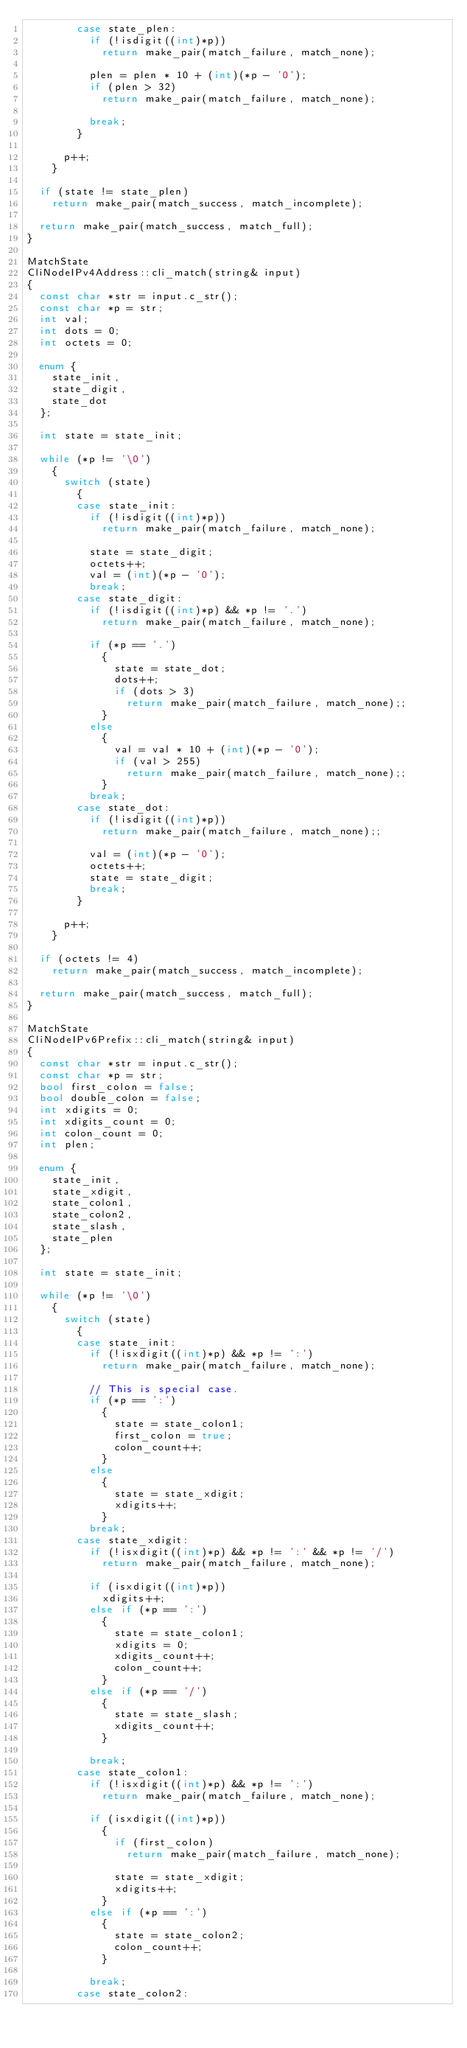<code> <loc_0><loc_0><loc_500><loc_500><_C++_>        case state_plen:
          if (!isdigit((int)*p))
            return make_pair(match_failure, match_none);

          plen = plen * 10 + (int)(*p - '0');
          if (plen > 32)
            return make_pair(match_failure, match_none);

          break;
        }

      p++;
    }

  if (state != state_plen)
    return make_pair(match_success, match_incomplete);

  return make_pair(match_success, match_full);
}

MatchState
CliNodeIPv4Address::cli_match(string& input)
{
  const char *str = input.c_str();
  const char *p = str;
  int val;
  int dots = 0;
  int octets = 0;

  enum {
    state_init,
    state_digit,
    state_dot
  };

  int state = state_init;

  while (*p != '\0')
    {
      switch (state)
        {
        case state_init:
          if (!isdigit((int)*p))
            return make_pair(match_failure, match_none);

          state = state_digit;
          octets++;
          val = (int)(*p - '0');
          break;
        case state_digit:
          if (!isdigit((int)*p) && *p != '.')
            return make_pair(match_failure, match_none);

          if (*p == '.')
            {
              state = state_dot;
              dots++;
              if (dots > 3)
                return make_pair(match_failure, match_none);;
            }
          else
            {
              val = val * 10 + (int)(*p - '0');
              if (val > 255)
                return make_pair(match_failure, match_none);;
            }
          break;
        case state_dot:
          if (!isdigit((int)*p))
            return make_pair(match_failure, match_none);;

          val = (int)(*p - '0');
          octets++;
          state = state_digit;
          break;
        }

      p++;
    }

  if (octets != 4)
    return make_pair(match_success, match_incomplete);

  return make_pair(match_success, match_full);
}

MatchState
CliNodeIPv6Prefix::cli_match(string& input)
{
  const char *str = input.c_str();
  const char *p = str;
  bool first_colon = false;
  bool double_colon = false;
  int xdigits = 0;
  int xdigits_count = 0;
  int colon_count = 0;
  int plen;

  enum {
    state_init,
    state_xdigit,
    state_colon1,
    state_colon2,
    state_slash,
    state_plen
  };

  int state = state_init;

  while (*p != '\0')
    {
      switch (state)
        {
        case state_init:
          if (!isxdigit((int)*p) && *p != ':')
            return make_pair(match_failure, match_none);

          // This is special case.
          if (*p == ':')
            {
              state = state_colon1;
              first_colon = true;
              colon_count++;
            }
          else
            {
              state = state_xdigit;
              xdigits++;
            }
          break;
        case state_xdigit:
          if (!isxdigit((int)*p) && *p != ':' && *p != '/')
            return make_pair(match_failure, match_none);

          if (isxdigit((int)*p))
            xdigits++;
          else if (*p == ':')
            {
              state = state_colon1;
              xdigits = 0;
              xdigits_count++;
              colon_count++;
            }
          else if (*p == '/')
            {
              state = state_slash;
              xdigits_count++;
            }

          break;
        case state_colon1:
          if (!isxdigit((int)*p) && *p != ':')
            return make_pair(match_failure, match_none);

          if (isxdigit((int)*p))
            {
              if (first_colon)
                return make_pair(match_failure, match_none);

              state = state_xdigit;
              xdigits++;
            }
          else if (*p == ':')
            {
              state = state_colon2;
              colon_count++;
            }

          break;
        case state_colon2:</code> 